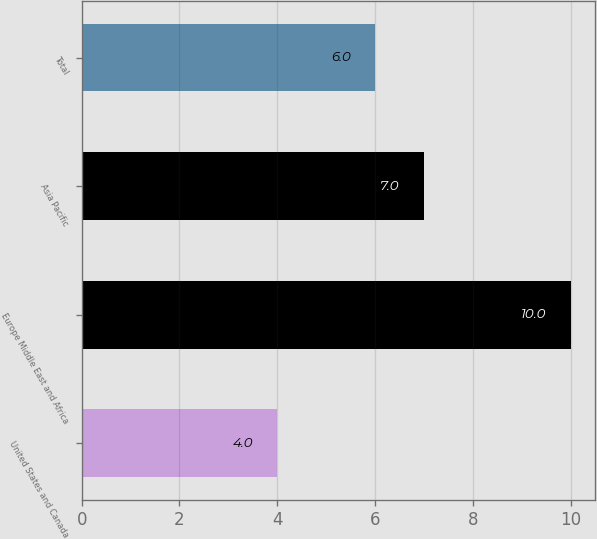Convert chart to OTSL. <chart><loc_0><loc_0><loc_500><loc_500><bar_chart><fcel>United States and Canada<fcel>Europe Middle East and Africa<fcel>Asia Pacific<fcel>Total<nl><fcel>4<fcel>10<fcel>7<fcel>6<nl></chart> 